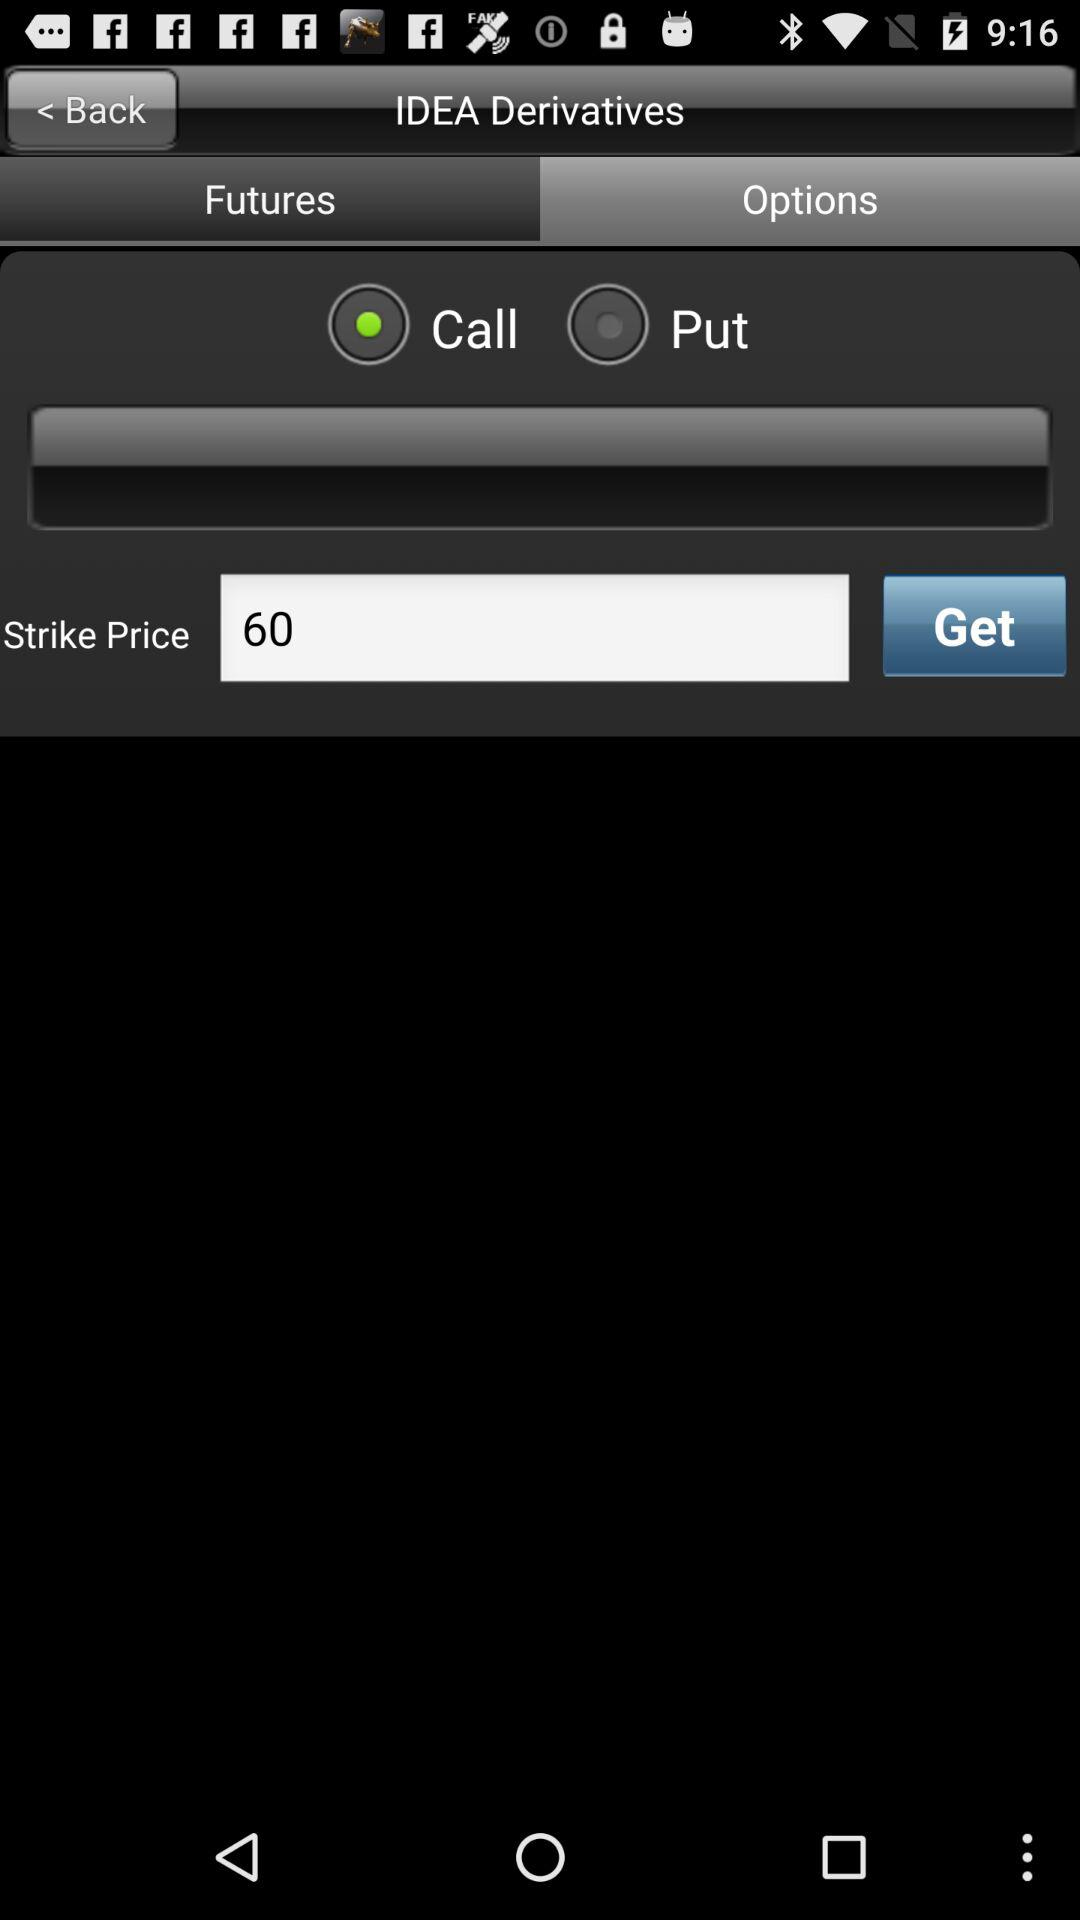Which option is selected? The selected options are "Options" and "Call". 